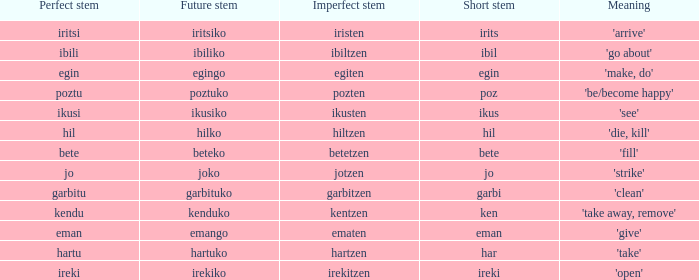What is the perfect stem for pozten? Poztu. 